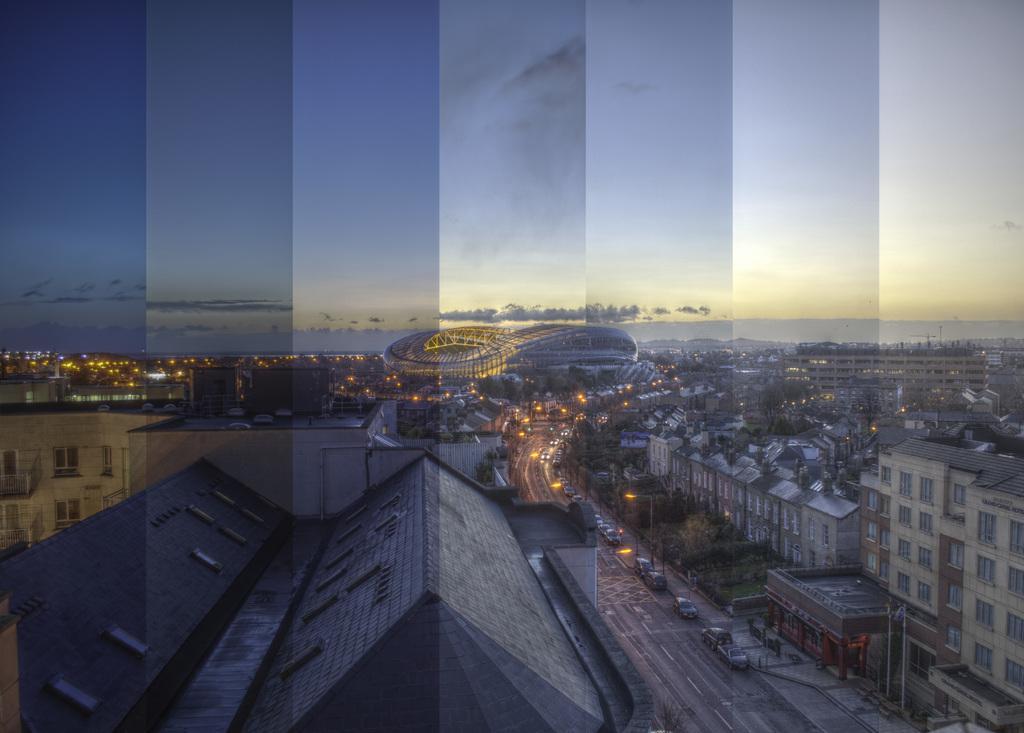Please provide a concise description of this image. In this image I can see few vehicles on the road, buildings in cream and gray color. Background I can see few trees, and sky in blue and white color. 